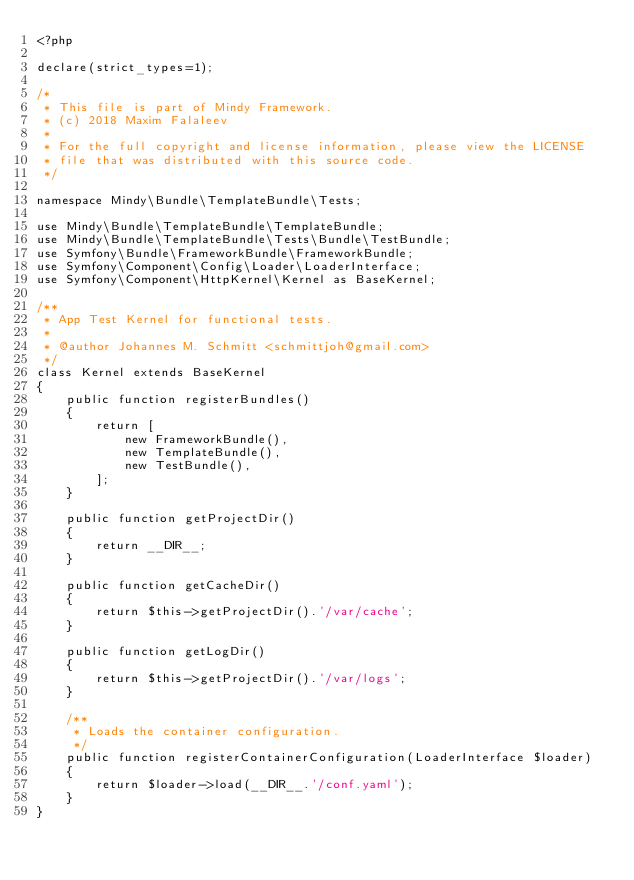Convert code to text. <code><loc_0><loc_0><loc_500><loc_500><_PHP_><?php

declare(strict_types=1);

/*
 * This file is part of Mindy Framework.
 * (c) 2018 Maxim Falaleev
 *
 * For the full copyright and license information, please view the LICENSE
 * file that was distributed with this source code.
 */

namespace Mindy\Bundle\TemplateBundle\Tests;

use Mindy\Bundle\TemplateBundle\TemplateBundle;
use Mindy\Bundle\TemplateBundle\Tests\Bundle\TestBundle;
use Symfony\Bundle\FrameworkBundle\FrameworkBundle;
use Symfony\Component\Config\Loader\LoaderInterface;
use Symfony\Component\HttpKernel\Kernel as BaseKernel;

/**
 * App Test Kernel for functional tests.
 *
 * @author Johannes M. Schmitt <schmittjoh@gmail.com>
 */
class Kernel extends BaseKernel
{
    public function registerBundles()
    {
        return [
            new FrameworkBundle(),
            new TemplateBundle(),
            new TestBundle(),
        ];
    }

    public function getProjectDir()
    {
        return __DIR__;
    }

    public function getCacheDir()
    {
        return $this->getProjectDir().'/var/cache';
    }

    public function getLogDir()
    {
        return $this->getProjectDir().'/var/logs';
    }

    /**
     * Loads the container configuration.
     */
    public function registerContainerConfiguration(LoaderInterface $loader)
    {
        return $loader->load(__DIR__.'/conf.yaml');
    }
}
</code> 